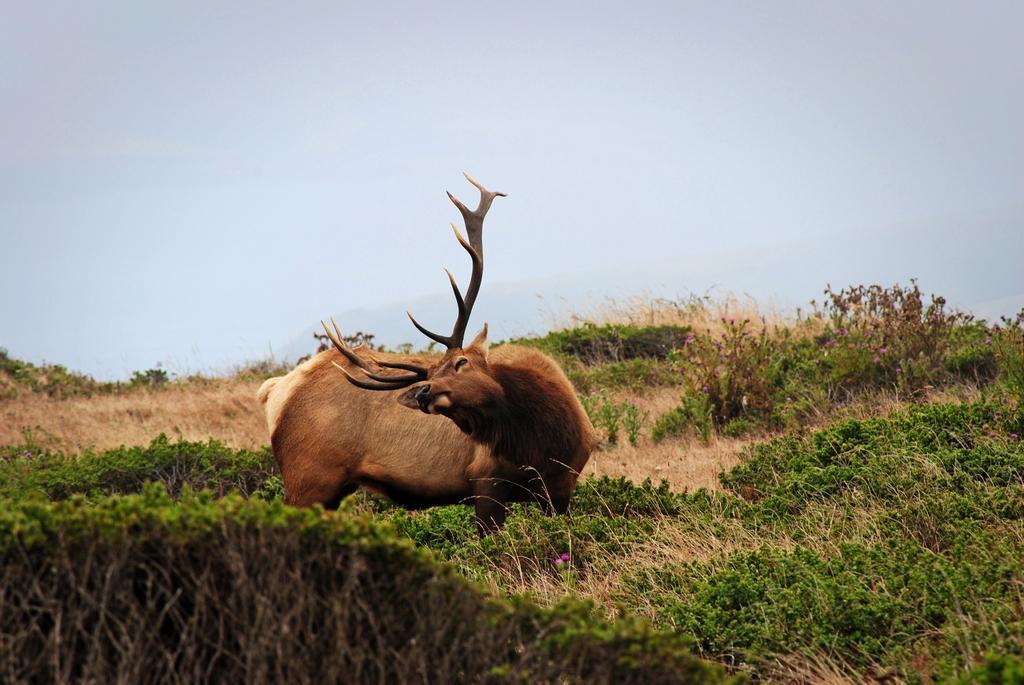Could you give a brief overview of what you see in this image? The picture is taken in a park. In the center of the picture there is an antelope. In the foreground there are plants and dry grass. Sky is foggy. 